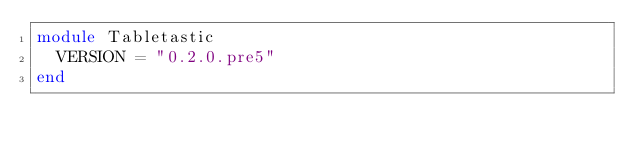Convert code to text. <code><loc_0><loc_0><loc_500><loc_500><_Ruby_>module Tabletastic
  VERSION = "0.2.0.pre5"
end</code> 